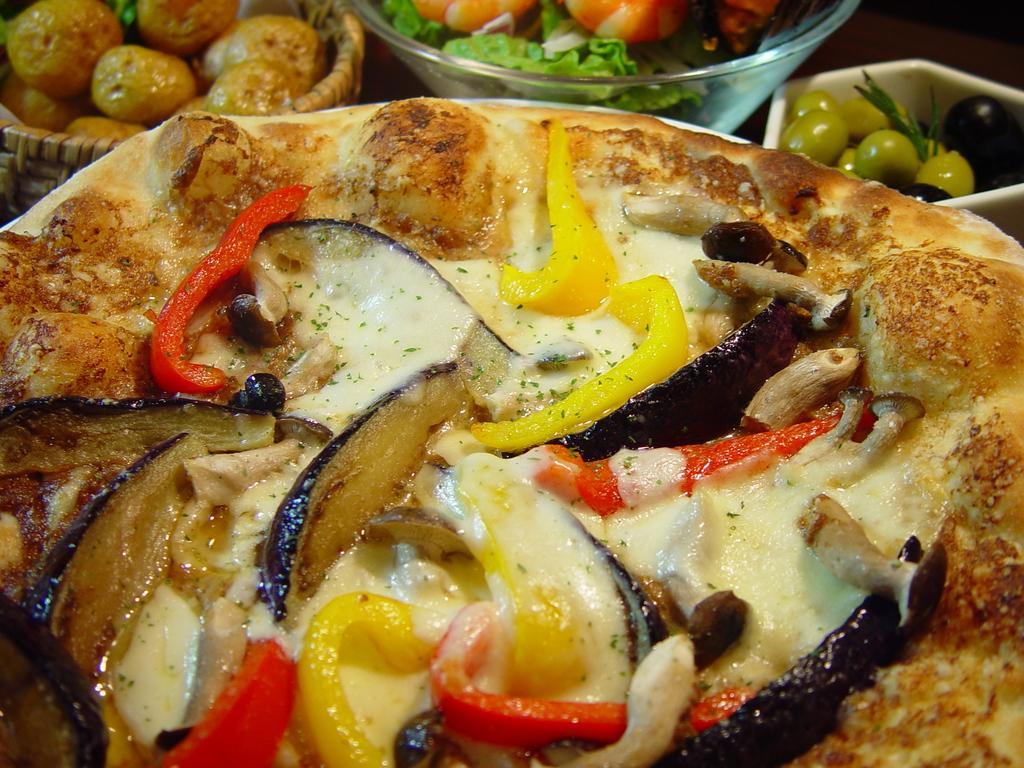Can you describe this image briefly? In the picture we can see a pizza with cheese and some vegetable slices on it and beside it we can see some bowl with some fruits and vegetables. 